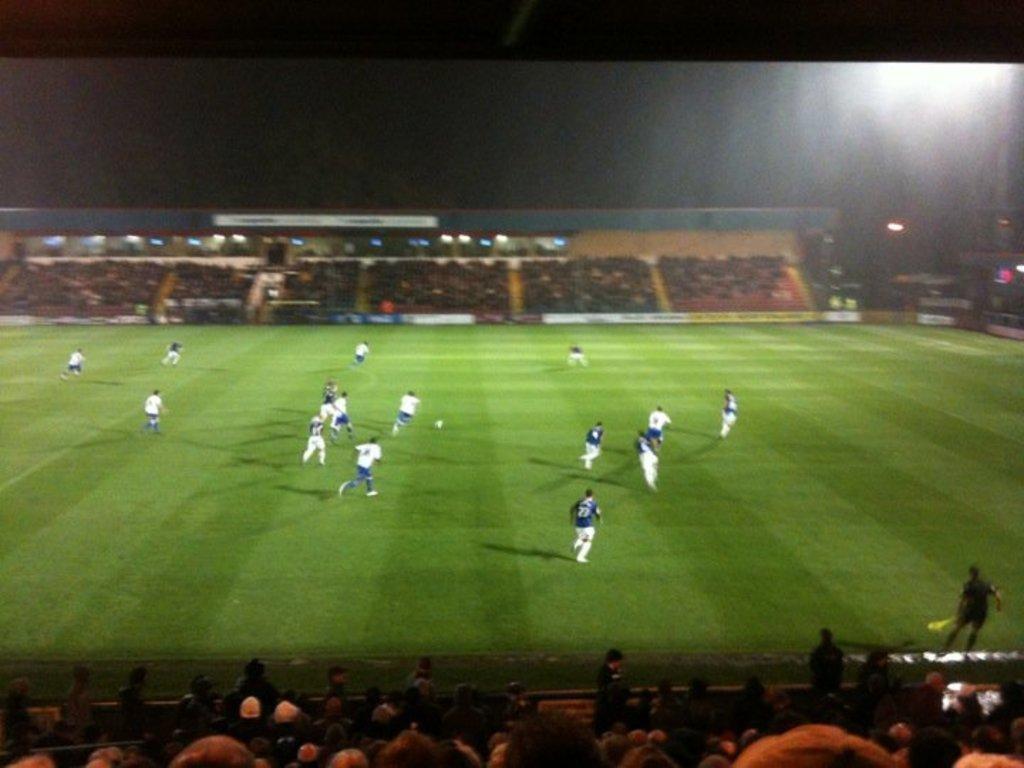Describe this image in one or two sentences. In this picture we can see a group of people playing the football on the ground and there are groups of people sitting and some people are standing in the stadium and behind the stadium there is a dark background. 